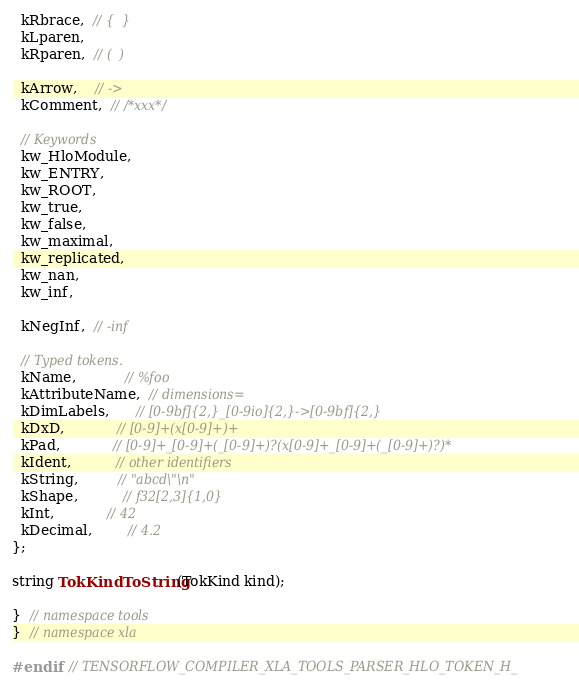<code> <loc_0><loc_0><loc_500><loc_500><_C_>  kRbrace,  // {  }
  kLparen,
  kRparen,  // (  )

  kArrow,    // ->
  kComment,  // /*xxx*/

  // Keywords
  kw_HloModule,
  kw_ENTRY,
  kw_ROOT,
  kw_true,
  kw_false,
  kw_maximal,
  kw_replicated,
  kw_nan,
  kw_inf,

  kNegInf,  // -inf

  // Typed tokens.
  kName,           // %foo
  kAttributeName,  // dimensions=
  kDimLabels,      // [0-9bf]{2,}_[0-9io]{2,}->[0-9bf]{2,}
  kDxD,            // [0-9]+(x[0-9]+)+
  kPad,            // [0-9]+_[0-9]+(_[0-9]+)?(x[0-9]+_[0-9]+(_[0-9]+)?)*
  kIdent,          // other identifiers
  kString,         // "abcd\"\n"
  kShape,          // f32[2,3]{1,0}
  kInt,            // 42
  kDecimal,        // 4.2
};

string TokKindToString(TokKind kind);

}  // namespace tools
}  // namespace xla

#endif  // TENSORFLOW_COMPILER_XLA_TOOLS_PARSER_HLO_TOKEN_H_
</code> 